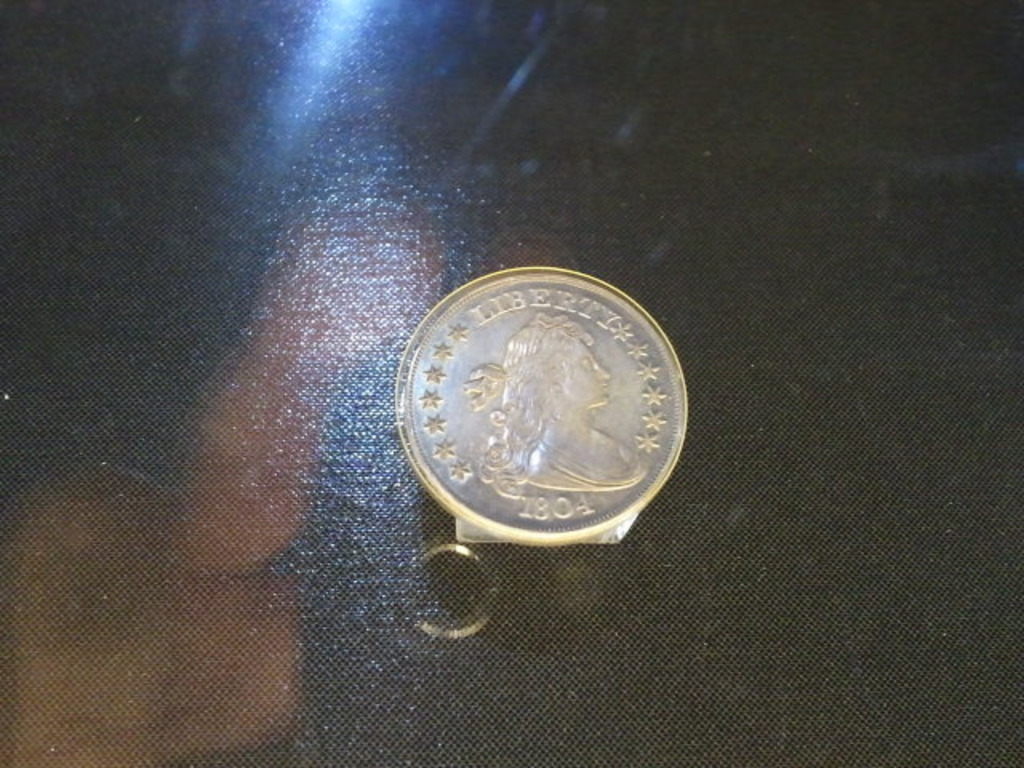What determines the value of a coin like the one in the image? The value of a coin like this is determined by several factors including its rarity, historical significance, condition or grade, and demand among collectors. For instance, an 1804 silver dollar's value escalates due to its status as a numismatic gem, and pristine examples can fetch millions at auction. Provenance—knowing the coin's ownership history—can also add to its allure and value. 